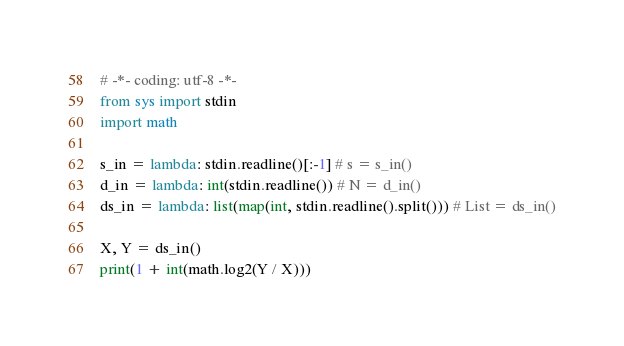Convert code to text. <code><loc_0><loc_0><loc_500><loc_500><_Python_># -*- coding: utf-8 -*-
from sys import stdin
import math

s_in = lambda: stdin.readline()[:-1] # s = s_in()
d_in = lambda: int(stdin.readline()) # N = d_in()
ds_in = lambda: list(map(int, stdin.readline().split())) # List = ds_in()

X, Y = ds_in()
print(1 + int(math.log2(Y / X)))
</code> 